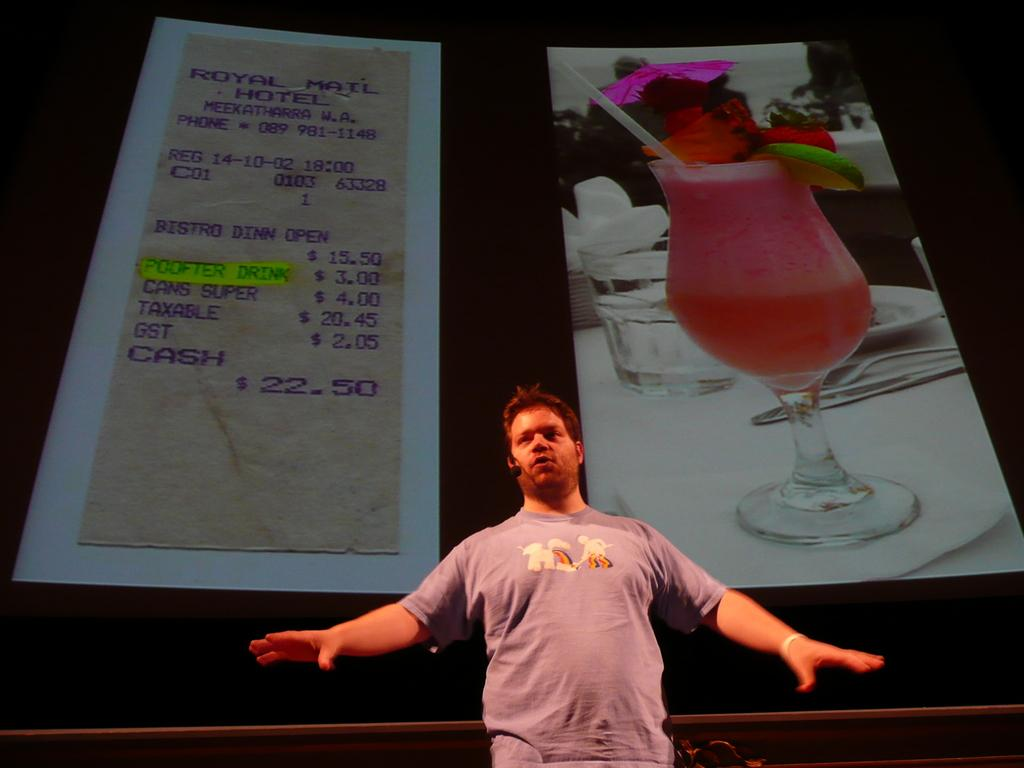What is the man in the image doing? The man is holding a mic and speaking. What is the man holding in his hand? The man is holding a mic. What can be seen in the middle of the image? There are two pictures in the middle of the image, one of a bill and the other of a glass. What type of toothpaste is the man using in the image? There is no toothpaste present in the image. Is the man swinging on a swing in the image? No, the man is not swinging on a swing in the image; he is holding a mic and speaking. 